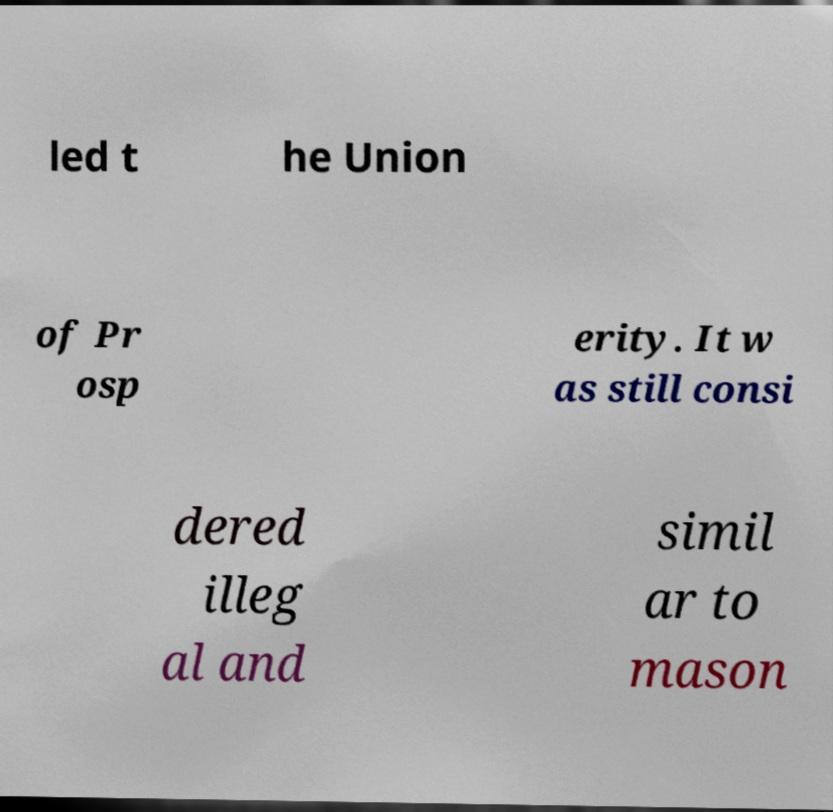Please read and relay the text visible in this image. What does it say? led t he Union of Pr osp erity. It w as still consi dered illeg al and simil ar to mason 